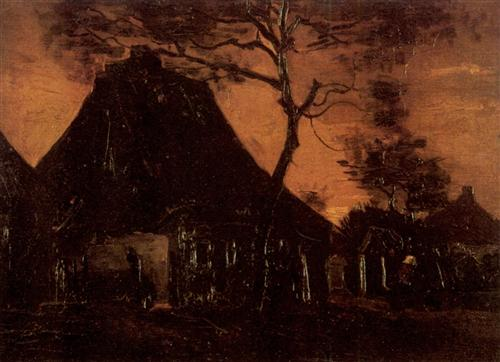What might be hidden within the dark shadows of the cottage? Within the dark shadows of the cottage, one might imagine hidden remnants of the past: an old rocking chair creaking gently with the breeze, dust-covered cooking pots, and perhaps a forgotten diary or letters packed with stories of the previous inhabitants. The shadows conceal the echoes of laughter, cries, and whispers that once filled this space, now merely a vestige of history. One could even envision finding dubious objects like an ancient key to an unknown place or a family heirloom with mysterious origins. The darkness holds an air of mystery, suggesting that while the physical presence is gone, the essence of life once lived clings to the hidden corners, waiting to be discovered by an intrepid soul daring to venture into the gloom. Tell me a fantastical story about what happened to the people who lived in the cottage. Once upon a time, the cottage under the ominous orange sky was home to a reclusive family of wizards who protected a small village in the valley nearby. The twisted tree was no ordinary tree but a magical sentinel that kept the cottage concealed from nefarious eyes. One fateful evening, as the sky glowed with an unnatural hue, a powerful sorcerer intent on seizing their ancient secrets stormed their abode. A fierce battle ensued, wands crackled with energy, and spellbooks fluttered open, casting enchantments that intertwined with the very fabric of the land. In a last heroic effort to protect their knowledge and the village, the family combined their powers and wove a spell of invisibility, rendering the cottage unseen and forgotten by the world. The family vanished, their spirits now guardians of the place, while the sorcerer, thwarted, was bound to roam the desolate landscape for eternity, their greed and malice confined by the spell. The cottage remains a solitary monument to their bravery, its secrets locked away in the shadows, waiting for a true-hearted explorer to uncover the legacy of the wizarding family. If this scene were part of a movie, describe the soundtrack that would accompany it. The soundtrack accompanying this scene in a movie would be a haunting composition, blending orchestral and ambient elements. It would begin with low, resonant strings creating a sense of foreboding, accompanied by a distant, echoing piano playing slow, melancholic notes. The wind through the barren tree would be softly mimicked by eerie woodwind instruments, while a chorus of ghostly, ethereal voices would add a layer of mysterious ambiance. As the scene progresses, subtle variations of these motifs would play, highlighting moments of tension or revealing fragments of the cottage's hidden history. This evocative score would immerse the audience in the desolation and mysterious allure of the landscape, enhancing the visual storytelling with a deeply emotional and atmospheric soundscape. 